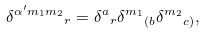<formula> <loc_0><loc_0><loc_500><loc_500>\delta ^ { \alpha ^ { \prime } { m _ { 1 } m _ { 2 } } } { _ { r } } = \delta ^ { a } { _ { r } } \delta ^ { m _ { 1 } } { _ { ( b } } \delta ^ { m _ { 2 } } { _ { c ) } } ,</formula> 